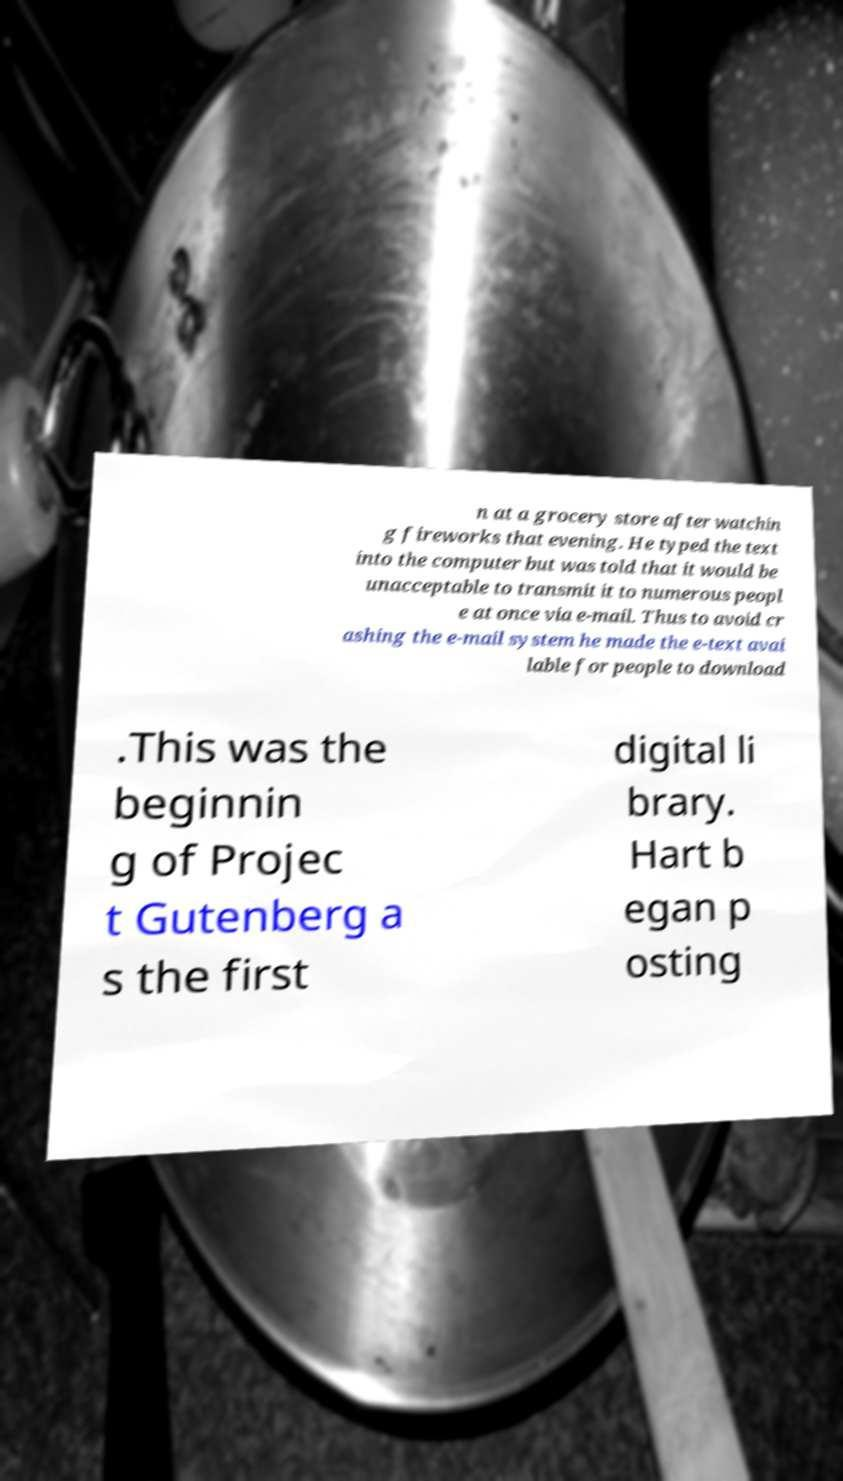What messages or text are displayed in this image? I need them in a readable, typed format. n at a grocery store after watchin g fireworks that evening. He typed the text into the computer but was told that it would be unacceptable to transmit it to numerous peopl e at once via e-mail. Thus to avoid cr ashing the e-mail system he made the e-text avai lable for people to download .This was the beginnin g of Projec t Gutenberg a s the first digital li brary. Hart b egan p osting 